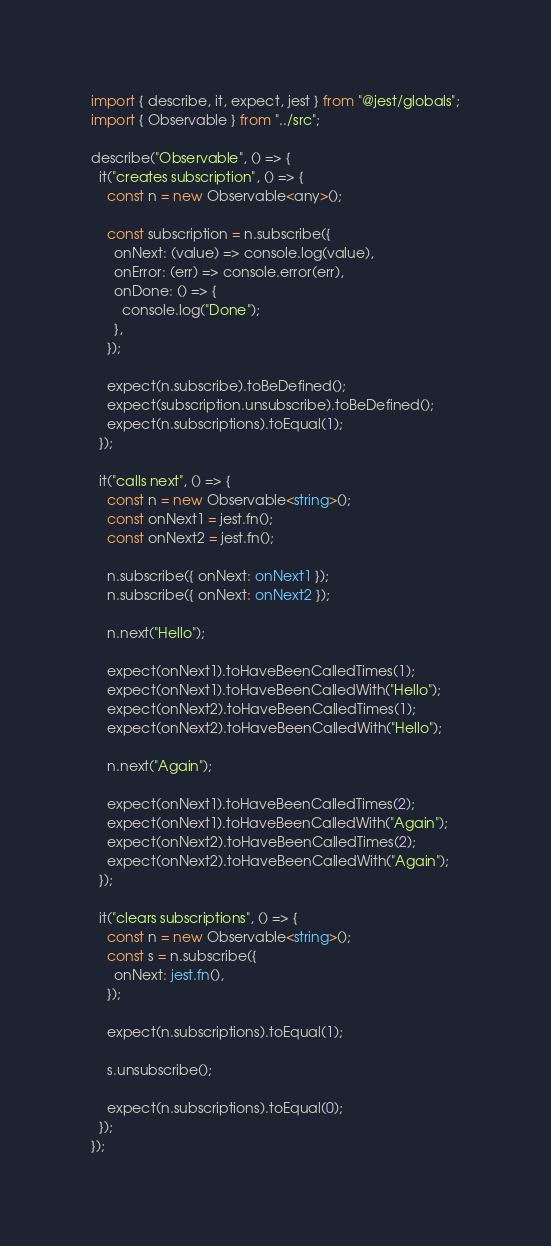Convert code to text. <code><loc_0><loc_0><loc_500><loc_500><_TypeScript_>import { describe, it, expect, jest } from "@jest/globals";
import { Observable } from "../src";

describe("Observable", () => {
  it("creates subscription", () => {
    const n = new Observable<any>();

    const subscription = n.subscribe({
      onNext: (value) => console.log(value),
      onError: (err) => console.error(err),
      onDone: () => {
        console.log("Done");
      },
    });

    expect(n.subscribe).toBeDefined();
    expect(subscription.unsubscribe).toBeDefined();
    expect(n.subscriptions).toEqual(1);
  });

  it("calls next", () => {
    const n = new Observable<string>();
    const onNext1 = jest.fn();
    const onNext2 = jest.fn();

    n.subscribe({ onNext: onNext1 });
    n.subscribe({ onNext: onNext2 });

    n.next("Hello");

    expect(onNext1).toHaveBeenCalledTimes(1);
    expect(onNext1).toHaveBeenCalledWith("Hello");
    expect(onNext2).toHaveBeenCalledTimes(1);
    expect(onNext2).toHaveBeenCalledWith("Hello");

    n.next("Again");

    expect(onNext1).toHaveBeenCalledTimes(2);
    expect(onNext1).toHaveBeenCalledWith("Again");
    expect(onNext2).toHaveBeenCalledTimes(2);
    expect(onNext2).toHaveBeenCalledWith("Again");
  });

  it("clears subscriptions", () => {
    const n = new Observable<string>();
    const s = n.subscribe({
      onNext: jest.fn(),
    });

    expect(n.subscriptions).toEqual(1);

    s.unsubscribe();

    expect(n.subscriptions).toEqual(0);
  });
});
</code> 